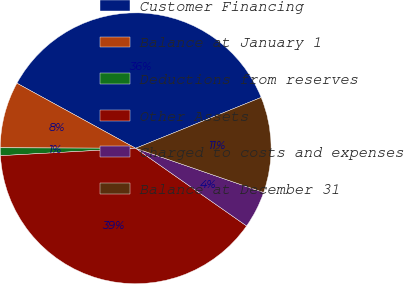<chart> <loc_0><loc_0><loc_500><loc_500><pie_chart><fcel>Customer Financing<fcel>Balance at January 1<fcel>Deductions from reserves<fcel>Other Assets<fcel>Charged to costs and expenses<fcel>Balance at December 31<nl><fcel>35.9%<fcel>7.92%<fcel>0.93%<fcel>39.4%<fcel>4.43%<fcel>11.42%<nl></chart> 